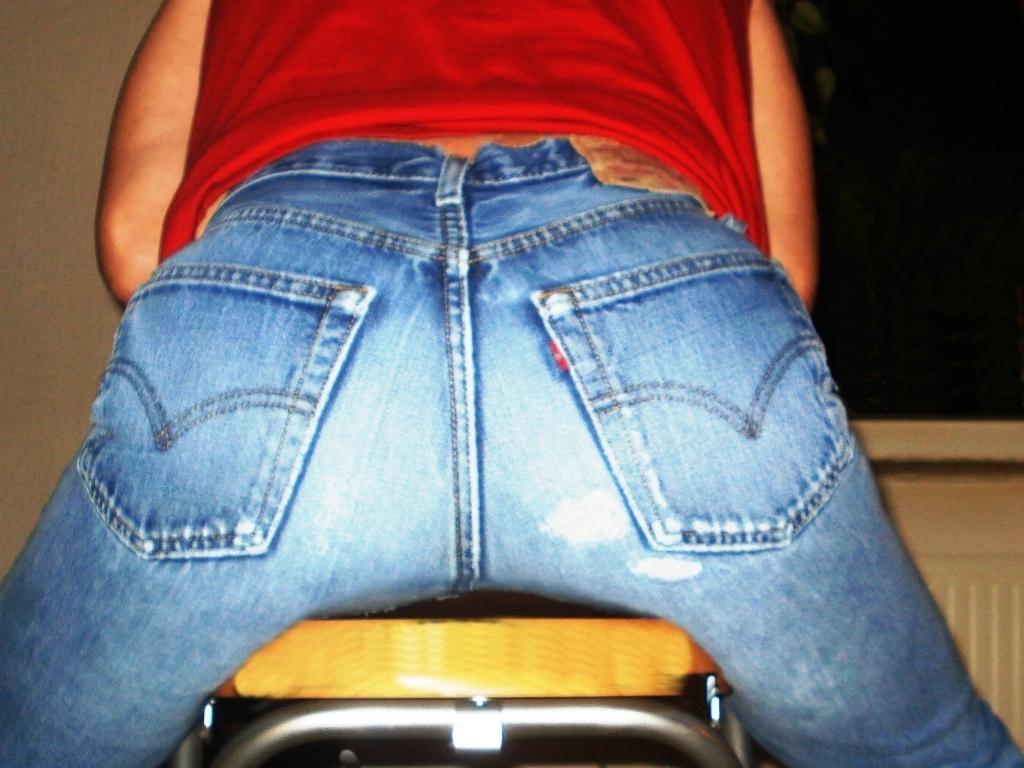How would you summarize this image in a sentence or two? In this picture I can see a person the person is wearing blue jeans and red color top. In the background i can see wall and object. 